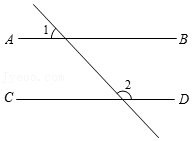First perform reasoning, then finally select the question from the choices in the following format: Answer: xxx.
Question: within the figure, AB is parallel to CD and angle 1 measures 56°. What is the measure of angle 2 in degrees?
Choices:
A: 134°
B: 128°
C: 124°
D: 114° As shown in the figure, angle 1 = 56°. Therefore, angle 3 = angle 1 = 56°. Since AB is parallel to CD, angle 2 + angle 3 = 180°. Therefore, angle 2 = 124°. Therefore, the correct answer is C.
Answer:C 